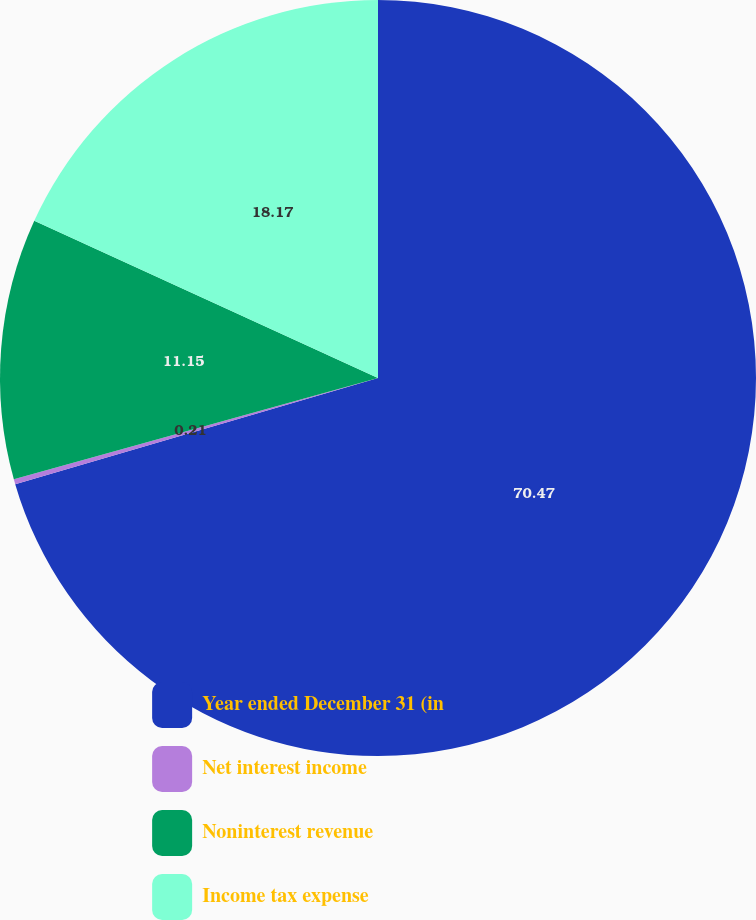<chart> <loc_0><loc_0><loc_500><loc_500><pie_chart><fcel>Year ended December 31 (in<fcel>Net interest income<fcel>Noninterest revenue<fcel>Income tax expense<nl><fcel>70.47%<fcel>0.21%<fcel>11.15%<fcel>18.17%<nl></chart> 